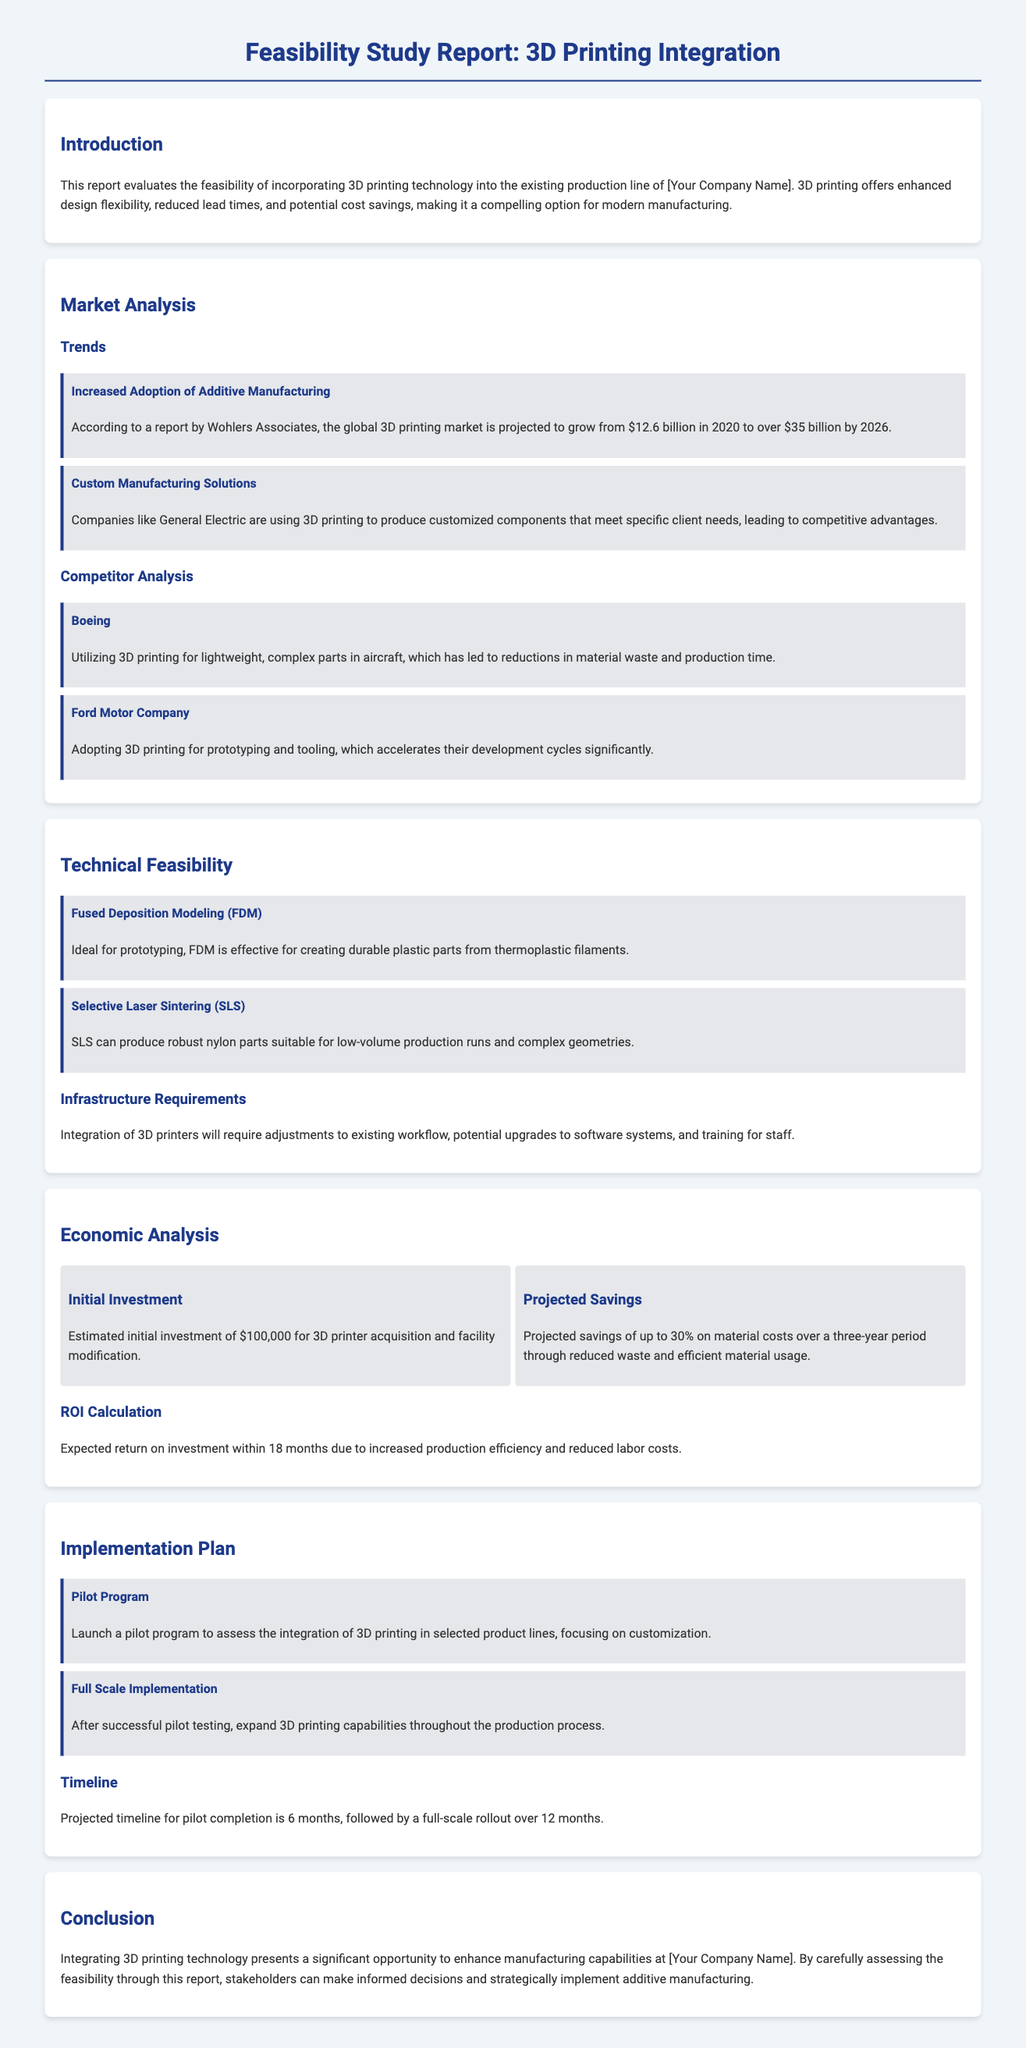What is the projected growth of the 3D printing market by 2026? The document states that the global 3D printing market is projected to grow from $12.6 billion in 2020 to over $35 billion by 2026.
Answer: over $35 billion What company is using 3D printing to produce customized components? The document mentions General Electric as a company utilizing 3D printing for customized components.
Answer: General Electric What is the estimated initial investment for 3D printer acquisition? The document states that the estimated initial investment is $100,000 for 3D printer acquisition and facility modification.
Answer: $100,000 What is the expected return on investment timeline? The document indicates that the expected return on investment is within 18 months due to increased production efficiency.
Answer: 18 months Which 3D printing method is ideal for prototyping? The document highlights Fused Deposition Modeling (FDM) as being effective for creating durable plastic parts.
Answer: Fused Deposition Modeling (FDM) What percentage of material cost savings is projected over a three-year period? The document mentions projected savings of up to 30% on material costs over three years through reduced waste.
Answer: up to 30% What is the timeline for pilot program completion? The document states that the projected timeline for pilot completion is 6 months.
Answer: 6 months How long is the full-scale rollout planned to take? The document indicates that the full-scale rollout is planned over 12 months after the pilot program.
Answer: 12 months What manufacturing process is Boeing using 3D printing for? The document describes that Boeing utilizes 3D printing for lightweight, complex parts in aircraft.
Answer: complex parts in aircraft 